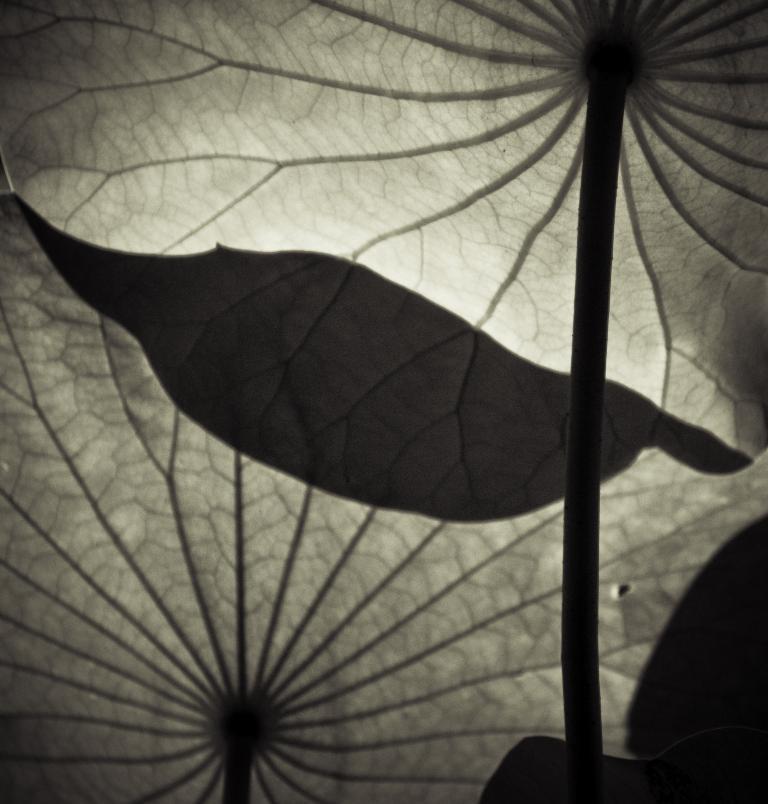Can you describe this image briefly? In this image we can see leaves on the stems of a plant. 